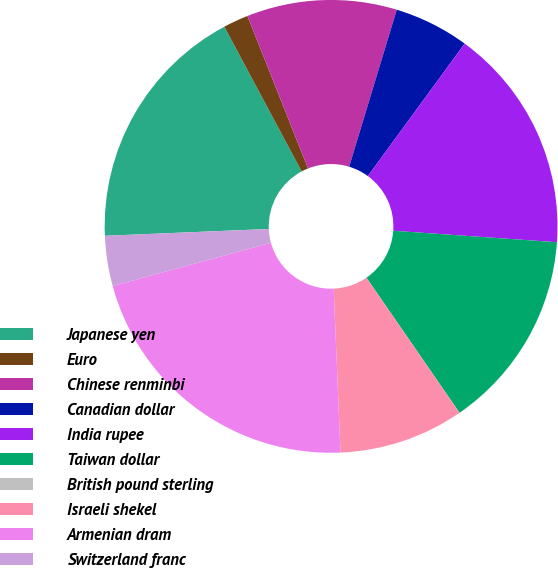Convert chart to OTSL. <chart><loc_0><loc_0><loc_500><loc_500><pie_chart><fcel>Japanese yen<fcel>Euro<fcel>Chinese renminbi<fcel>Canadian dollar<fcel>India rupee<fcel>Taiwan dollar<fcel>British pound sterling<fcel>Israeli shekel<fcel>Armenian dram<fcel>Switzerland franc<nl><fcel>17.85%<fcel>1.79%<fcel>10.71%<fcel>5.36%<fcel>16.07%<fcel>14.28%<fcel>0.01%<fcel>8.93%<fcel>21.42%<fcel>3.58%<nl></chart> 